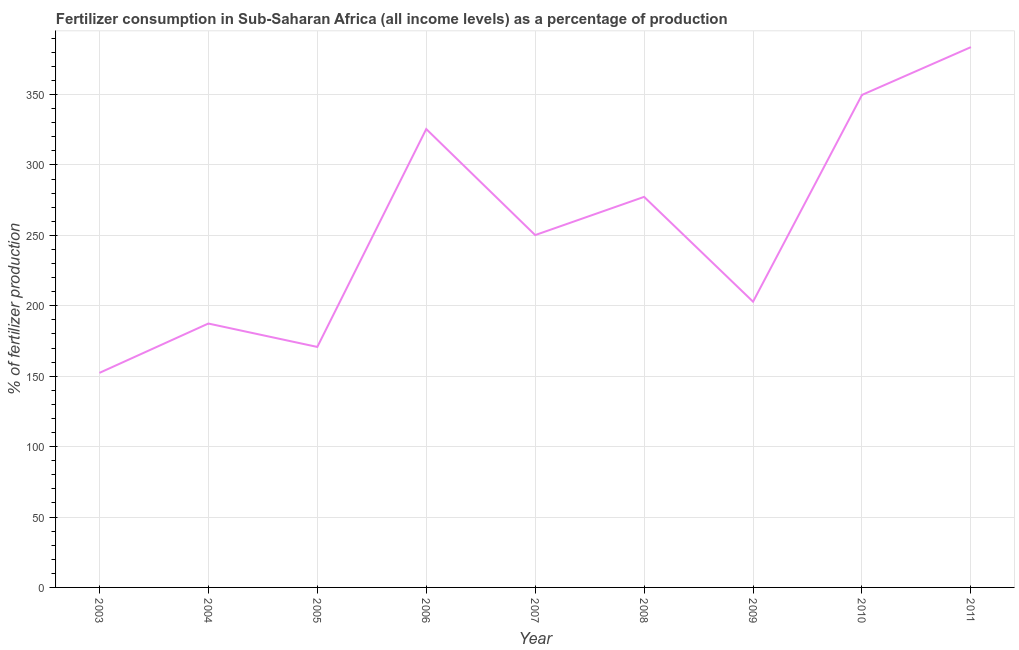What is the amount of fertilizer consumption in 2006?
Make the answer very short. 325.51. Across all years, what is the maximum amount of fertilizer consumption?
Keep it short and to the point. 383.69. Across all years, what is the minimum amount of fertilizer consumption?
Make the answer very short. 152.35. In which year was the amount of fertilizer consumption maximum?
Your answer should be compact. 2011. In which year was the amount of fertilizer consumption minimum?
Ensure brevity in your answer.  2003. What is the sum of the amount of fertilizer consumption?
Make the answer very short. 2299.93. What is the difference between the amount of fertilizer consumption in 2009 and 2010?
Provide a succinct answer. -146.83. What is the average amount of fertilizer consumption per year?
Make the answer very short. 255.55. What is the median amount of fertilizer consumption?
Offer a terse response. 250.2. In how many years, is the amount of fertilizer consumption greater than 80 %?
Make the answer very short. 9. Do a majority of the years between 2003 and 2005 (inclusive) have amount of fertilizer consumption greater than 360 %?
Keep it short and to the point. No. What is the ratio of the amount of fertilizer consumption in 2005 to that in 2007?
Your response must be concise. 0.68. What is the difference between the highest and the second highest amount of fertilizer consumption?
Your answer should be very brief. 33.95. What is the difference between the highest and the lowest amount of fertilizer consumption?
Your response must be concise. 231.34. Does the amount of fertilizer consumption monotonically increase over the years?
Offer a very short reply. No. How many lines are there?
Keep it short and to the point. 1. How many years are there in the graph?
Ensure brevity in your answer.  9. What is the difference between two consecutive major ticks on the Y-axis?
Offer a very short reply. 50. Does the graph contain any zero values?
Offer a terse response. No. Does the graph contain grids?
Provide a succinct answer. Yes. What is the title of the graph?
Your response must be concise. Fertilizer consumption in Sub-Saharan Africa (all income levels) as a percentage of production. What is the label or title of the Y-axis?
Your answer should be compact. % of fertilizer production. What is the % of fertilizer production in 2003?
Make the answer very short. 152.35. What is the % of fertilizer production in 2004?
Offer a terse response. 187.4. What is the % of fertilizer production of 2005?
Offer a terse response. 170.78. What is the % of fertilizer production in 2006?
Your answer should be compact. 325.51. What is the % of fertilizer production in 2007?
Provide a succinct answer. 250.2. What is the % of fertilizer production in 2008?
Your response must be concise. 277.34. What is the % of fertilizer production in 2009?
Make the answer very short. 202.92. What is the % of fertilizer production in 2010?
Make the answer very short. 349.74. What is the % of fertilizer production of 2011?
Provide a short and direct response. 383.69. What is the difference between the % of fertilizer production in 2003 and 2004?
Your answer should be very brief. -35.04. What is the difference between the % of fertilizer production in 2003 and 2005?
Keep it short and to the point. -18.43. What is the difference between the % of fertilizer production in 2003 and 2006?
Keep it short and to the point. -173.16. What is the difference between the % of fertilizer production in 2003 and 2007?
Provide a short and direct response. -97.85. What is the difference between the % of fertilizer production in 2003 and 2008?
Your answer should be compact. -124.99. What is the difference between the % of fertilizer production in 2003 and 2009?
Your answer should be very brief. -50.56. What is the difference between the % of fertilizer production in 2003 and 2010?
Provide a succinct answer. -197.39. What is the difference between the % of fertilizer production in 2003 and 2011?
Keep it short and to the point. -231.34. What is the difference between the % of fertilizer production in 2004 and 2005?
Your answer should be compact. 16.62. What is the difference between the % of fertilizer production in 2004 and 2006?
Offer a terse response. -138.11. What is the difference between the % of fertilizer production in 2004 and 2007?
Your answer should be very brief. -62.81. What is the difference between the % of fertilizer production in 2004 and 2008?
Ensure brevity in your answer.  -89.94. What is the difference between the % of fertilizer production in 2004 and 2009?
Your answer should be compact. -15.52. What is the difference between the % of fertilizer production in 2004 and 2010?
Ensure brevity in your answer.  -162.35. What is the difference between the % of fertilizer production in 2004 and 2011?
Provide a succinct answer. -196.29. What is the difference between the % of fertilizer production in 2005 and 2006?
Provide a succinct answer. -154.73. What is the difference between the % of fertilizer production in 2005 and 2007?
Your answer should be compact. -79.43. What is the difference between the % of fertilizer production in 2005 and 2008?
Keep it short and to the point. -106.56. What is the difference between the % of fertilizer production in 2005 and 2009?
Your response must be concise. -32.14. What is the difference between the % of fertilizer production in 2005 and 2010?
Provide a short and direct response. -178.97. What is the difference between the % of fertilizer production in 2005 and 2011?
Ensure brevity in your answer.  -212.91. What is the difference between the % of fertilizer production in 2006 and 2007?
Provide a short and direct response. 75.31. What is the difference between the % of fertilizer production in 2006 and 2008?
Offer a terse response. 48.17. What is the difference between the % of fertilizer production in 2006 and 2009?
Give a very brief answer. 122.59. What is the difference between the % of fertilizer production in 2006 and 2010?
Make the answer very short. -24.23. What is the difference between the % of fertilizer production in 2006 and 2011?
Ensure brevity in your answer.  -58.18. What is the difference between the % of fertilizer production in 2007 and 2008?
Provide a short and direct response. -27.14. What is the difference between the % of fertilizer production in 2007 and 2009?
Your answer should be compact. 47.29. What is the difference between the % of fertilizer production in 2007 and 2010?
Give a very brief answer. -99.54. What is the difference between the % of fertilizer production in 2007 and 2011?
Offer a very short reply. -133.49. What is the difference between the % of fertilizer production in 2008 and 2009?
Provide a short and direct response. 74.42. What is the difference between the % of fertilizer production in 2008 and 2010?
Your answer should be very brief. -72.4. What is the difference between the % of fertilizer production in 2008 and 2011?
Make the answer very short. -106.35. What is the difference between the % of fertilizer production in 2009 and 2010?
Ensure brevity in your answer.  -146.83. What is the difference between the % of fertilizer production in 2009 and 2011?
Offer a terse response. -180.77. What is the difference between the % of fertilizer production in 2010 and 2011?
Give a very brief answer. -33.95. What is the ratio of the % of fertilizer production in 2003 to that in 2004?
Provide a short and direct response. 0.81. What is the ratio of the % of fertilizer production in 2003 to that in 2005?
Make the answer very short. 0.89. What is the ratio of the % of fertilizer production in 2003 to that in 2006?
Your answer should be very brief. 0.47. What is the ratio of the % of fertilizer production in 2003 to that in 2007?
Make the answer very short. 0.61. What is the ratio of the % of fertilizer production in 2003 to that in 2008?
Provide a short and direct response. 0.55. What is the ratio of the % of fertilizer production in 2003 to that in 2009?
Your answer should be compact. 0.75. What is the ratio of the % of fertilizer production in 2003 to that in 2010?
Your response must be concise. 0.44. What is the ratio of the % of fertilizer production in 2003 to that in 2011?
Give a very brief answer. 0.4. What is the ratio of the % of fertilizer production in 2004 to that in 2005?
Keep it short and to the point. 1.1. What is the ratio of the % of fertilizer production in 2004 to that in 2006?
Offer a very short reply. 0.58. What is the ratio of the % of fertilizer production in 2004 to that in 2007?
Your response must be concise. 0.75. What is the ratio of the % of fertilizer production in 2004 to that in 2008?
Your response must be concise. 0.68. What is the ratio of the % of fertilizer production in 2004 to that in 2009?
Offer a very short reply. 0.92. What is the ratio of the % of fertilizer production in 2004 to that in 2010?
Provide a short and direct response. 0.54. What is the ratio of the % of fertilizer production in 2004 to that in 2011?
Ensure brevity in your answer.  0.49. What is the ratio of the % of fertilizer production in 2005 to that in 2006?
Offer a very short reply. 0.53. What is the ratio of the % of fertilizer production in 2005 to that in 2007?
Provide a short and direct response. 0.68. What is the ratio of the % of fertilizer production in 2005 to that in 2008?
Keep it short and to the point. 0.62. What is the ratio of the % of fertilizer production in 2005 to that in 2009?
Provide a succinct answer. 0.84. What is the ratio of the % of fertilizer production in 2005 to that in 2010?
Provide a short and direct response. 0.49. What is the ratio of the % of fertilizer production in 2005 to that in 2011?
Offer a terse response. 0.45. What is the ratio of the % of fertilizer production in 2006 to that in 2007?
Offer a very short reply. 1.3. What is the ratio of the % of fertilizer production in 2006 to that in 2008?
Offer a very short reply. 1.17. What is the ratio of the % of fertilizer production in 2006 to that in 2009?
Your response must be concise. 1.6. What is the ratio of the % of fertilizer production in 2006 to that in 2011?
Ensure brevity in your answer.  0.85. What is the ratio of the % of fertilizer production in 2007 to that in 2008?
Provide a short and direct response. 0.9. What is the ratio of the % of fertilizer production in 2007 to that in 2009?
Your answer should be very brief. 1.23. What is the ratio of the % of fertilizer production in 2007 to that in 2010?
Make the answer very short. 0.71. What is the ratio of the % of fertilizer production in 2007 to that in 2011?
Your response must be concise. 0.65. What is the ratio of the % of fertilizer production in 2008 to that in 2009?
Your response must be concise. 1.37. What is the ratio of the % of fertilizer production in 2008 to that in 2010?
Offer a terse response. 0.79. What is the ratio of the % of fertilizer production in 2008 to that in 2011?
Offer a terse response. 0.72. What is the ratio of the % of fertilizer production in 2009 to that in 2010?
Offer a very short reply. 0.58. What is the ratio of the % of fertilizer production in 2009 to that in 2011?
Keep it short and to the point. 0.53. What is the ratio of the % of fertilizer production in 2010 to that in 2011?
Keep it short and to the point. 0.91. 